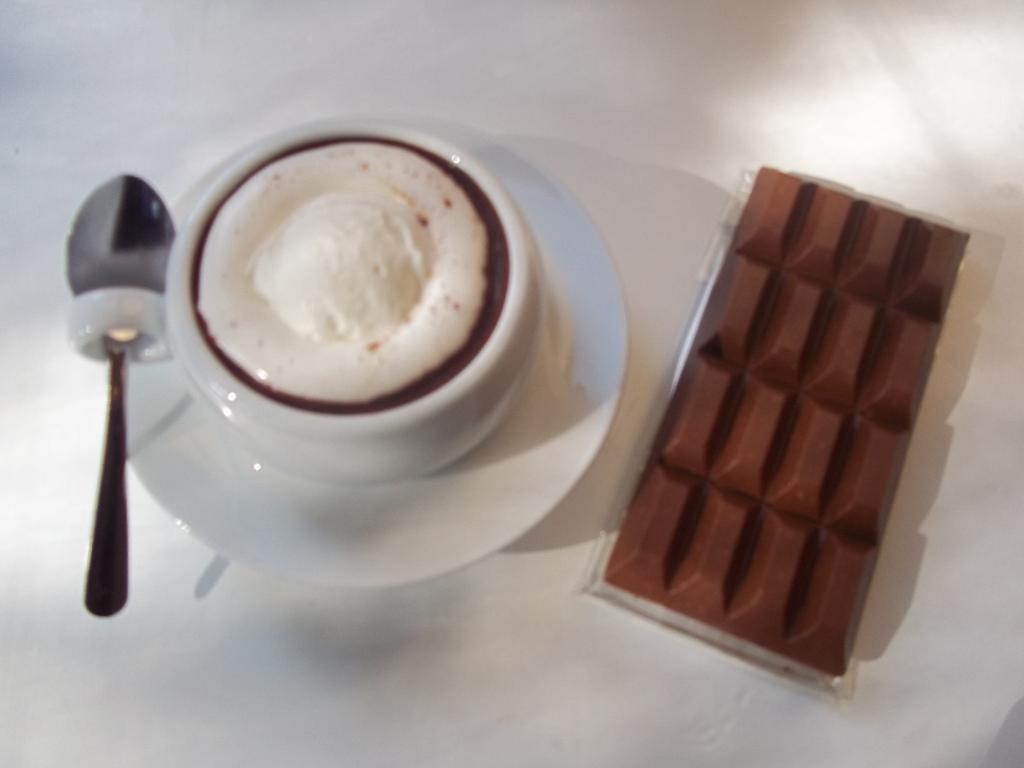What is in the cup that is visible in the image? There is a cup of tea in the image. What object is on the left side of the image? There is a spoon on the left side of the image. What type of food is on the right side of the image? There is a chocolate bar on the right side of the image. Can you tell me how many times the twig jumps in the image? There is no twig present in the image, and therefore no jumping can be observed. 